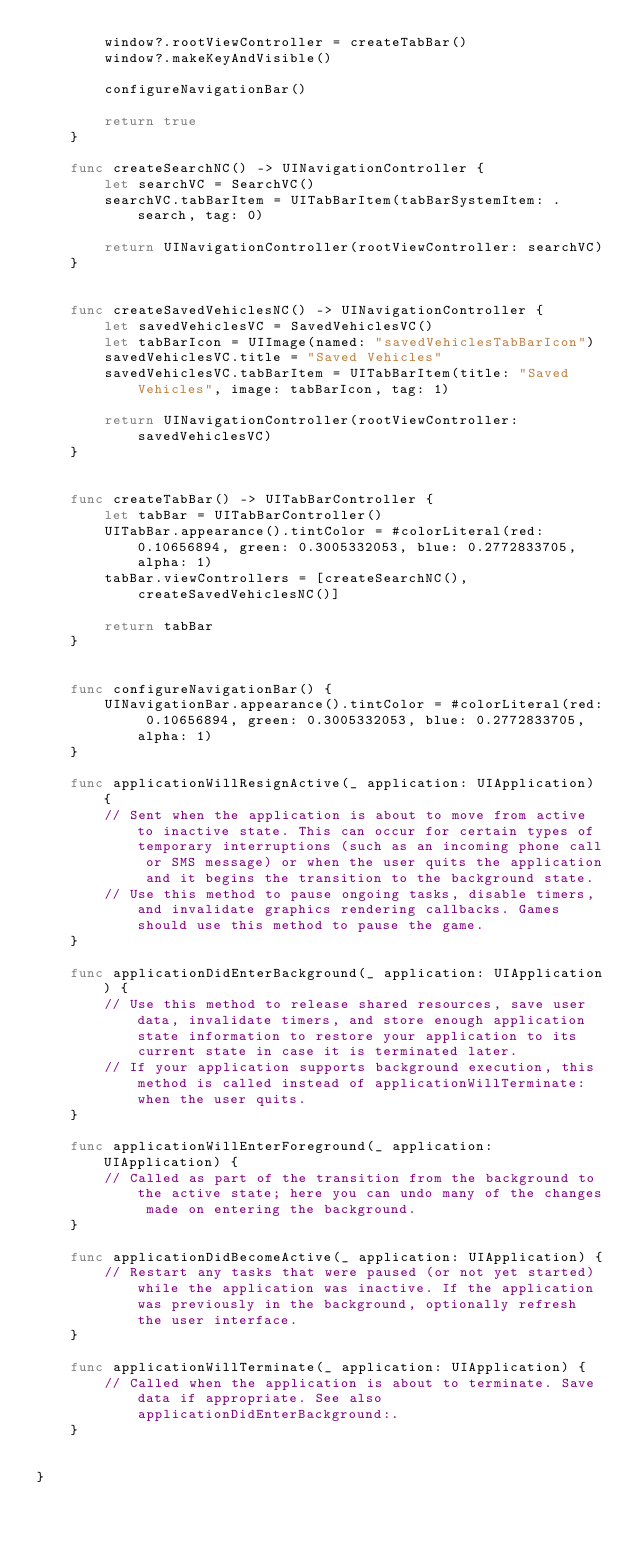<code> <loc_0><loc_0><loc_500><loc_500><_Swift_>        window?.rootViewController = createTabBar()
        window?.makeKeyAndVisible()
        
        configureNavigationBar()
        
        return true
    }
    
    func createSearchNC() -> UINavigationController {
        let searchVC = SearchVC()
        searchVC.tabBarItem = UITabBarItem(tabBarSystemItem: .search, tag: 0)
        
        return UINavigationController(rootViewController: searchVC)
    }
    
    
    func createSavedVehiclesNC() -> UINavigationController {
        let savedVehiclesVC = SavedVehiclesVC()
        let tabBarIcon = UIImage(named: "savedVehiclesTabBarIcon")
        savedVehiclesVC.title = "Saved Vehicles"
        savedVehiclesVC.tabBarItem = UITabBarItem(title: "Saved Vehicles", image: tabBarIcon, tag: 1)
        
        return UINavigationController(rootViewController: savedVehiclesVC)
    }
    
    
    func createTabBar() -> UITabBarController {
        let tabBar = UITabBarController()
        UITabBar.appearance().tintColor = #colorLiteral(red: 0.10656894, green: 0.3005332053, blue: 0.2772833705, alpha: 1)
        tabBar.viewControllers = [createSearchNC(), createSavedVehiclesNC()]
        
        return tabBar
    }
    
    
    func configureNavigationBar() {
        UINavigationBar.appearance().tintColor = #colorLiteral(red: 0.10656894, green: 0.3005332053, blue: 0.2772833705, alpha: 1)
    }

    func applicationWillResignActive(_ application: UIApplication) {
        // Sent when the application is about to move from active to inactive state. This can occur for certain types of temporary interruptions (such as an incoming phone call or SMS message) or when the user quits the application and it begins the transition to the background state.
        // Use this method to pause ongoing tasks, disable timers, and invalidate graphics rendering callbacks. Games should use this method to pause the game.
    }

    func applicationDidEnterBackground(_ application: UIApplication) {
        // Use this method to release shared resources, save user data, invalidate timers, and store enough application state information to restore your application to its current state in case it is terminated later.
        // If your application supports background execution, this method is called instead of applicationWillTerminate: when the user quits.
    }

    func applicationWillEnterForeground(_ application: UIApplication) {
        // Called as part of the transition from the background to the active state; here you can undo many of the changes made on entering the background.
    }

    func applicationDidBecomeActive(_ application: UIApplication) {
        // Restart any tasks that were paused (or not yet started) while the application was inactive. If the application was previously in the background, optionally refresh the user interface.
    }

    func applicationWillTerminate(_ application: UIApplication) {
        // Called when the application is about to terminate. Save data if appropriate. See also applicationDidEnterBackground:.
    }


}

</code> 